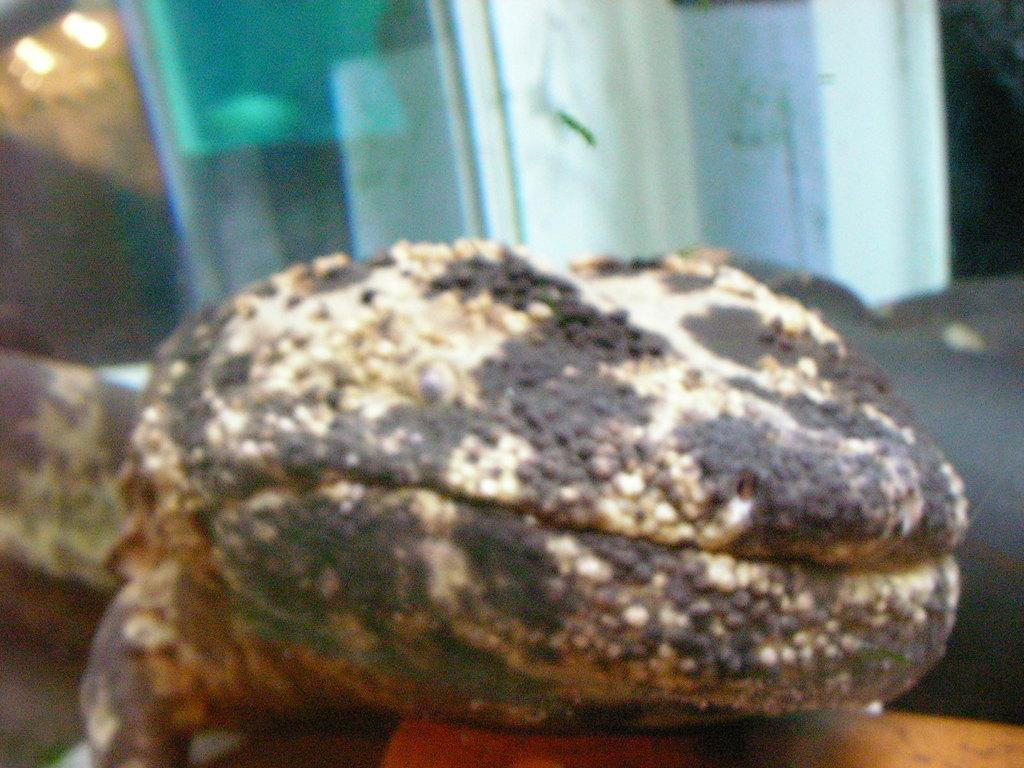What type of creature is present in the image? There is an animal in the image. Can you describe the position or location of the animal in the image? The animal is on an object. How many tickets are required to trade for the animal in the image? There is no mention of tickets or trading in the image, so it is not possible to answer that question. 